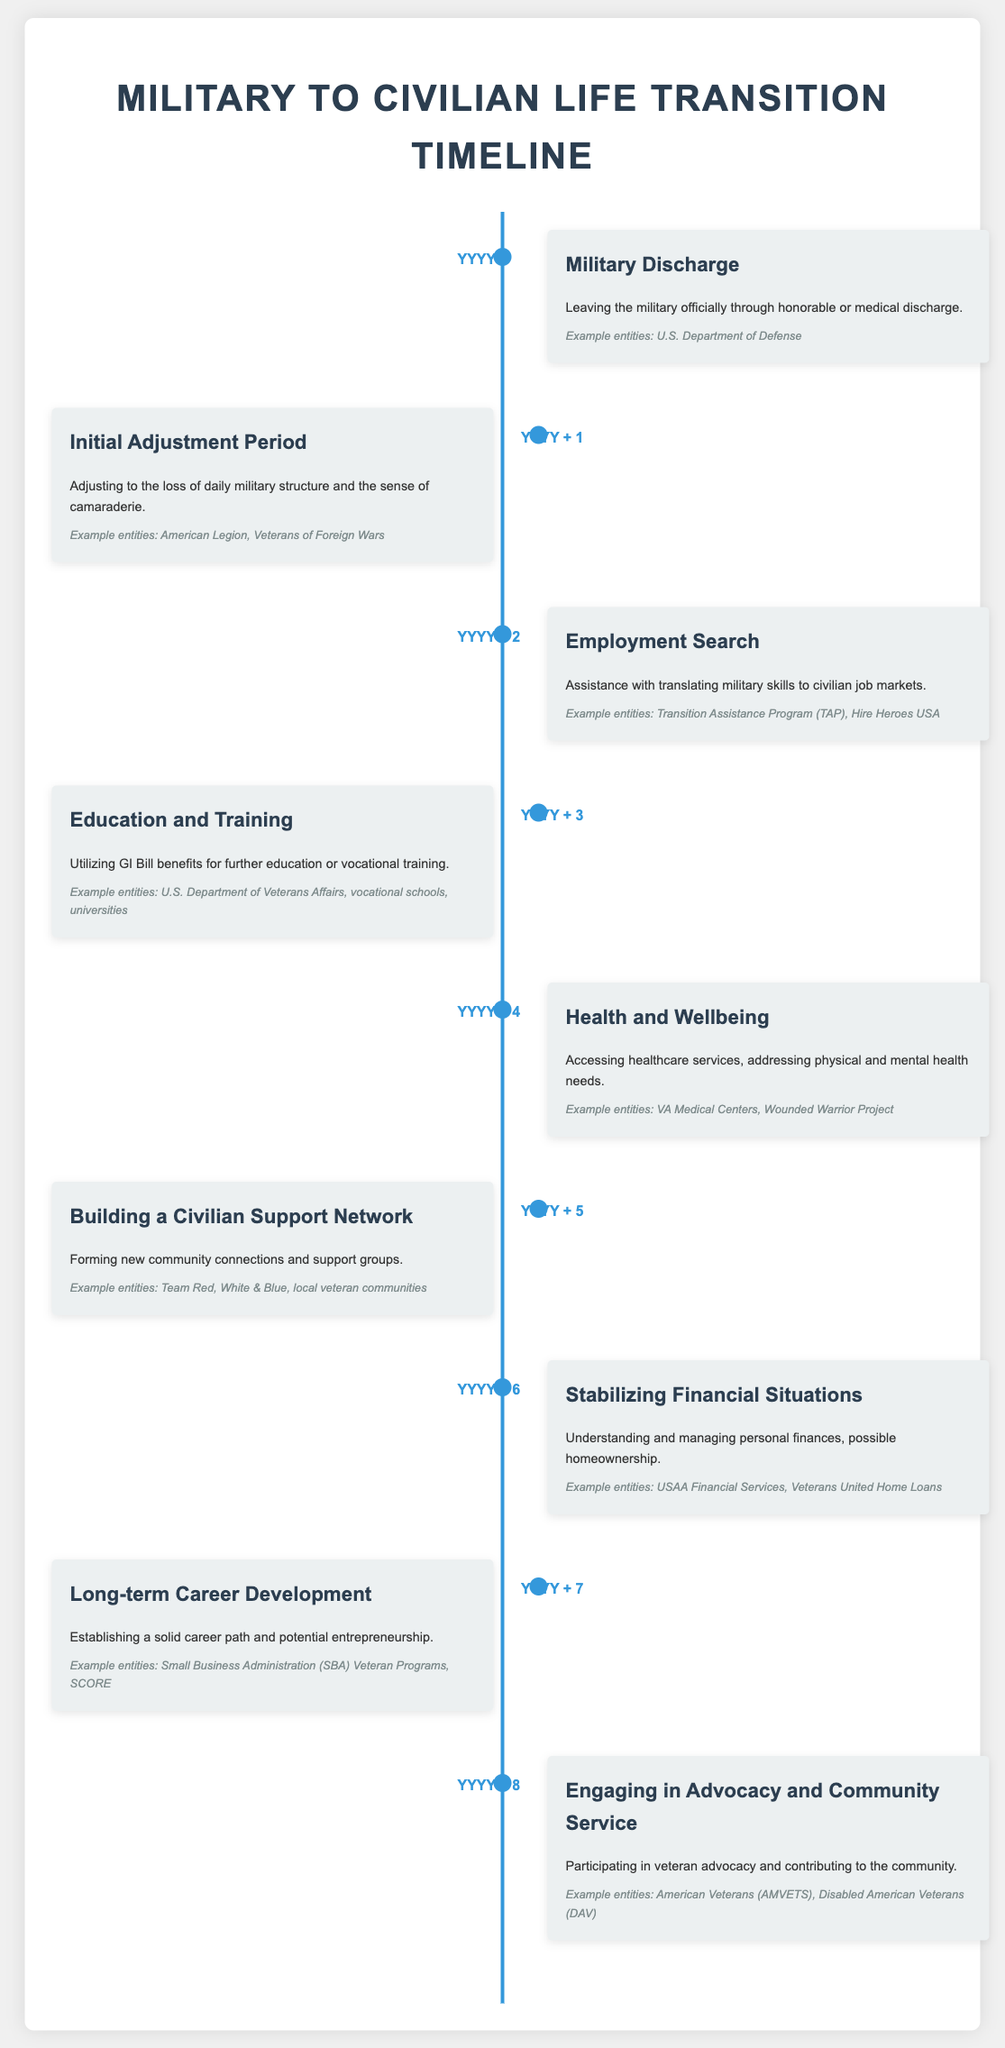What is the first milestone in the timeline? The first milestone refers to the initial event in the transition timeline, which is "Military Discharge."
Answer: Military Discharge What year does the "Employment Search" milestone occur? The "Employment Search" milestone occurs two years after the military discharge, marking it as "YYYY + 2."
Answer: YYYY + 2 What assistance program is mentioned for translating military skills? The document lists "Transition Assistance Program (TAP)" as one option for assistance.
Answer: Transition Assistance Program (TAP) What is a major focus during the "Health and Wellbeing" milestone? This milestone emphasizes the importance of accessing healthcare services and addressing both physical and mental health needs.
Answer: Accessing healthcare services Which entity is associated with community connections and support groups? The timeline includes "Team Red, White & Blue" as an example entity for building a civilian support network.
Answer: Team Red, White & Blue How long after military discharge do veterans begin "Long-term Career Development"? The timeline indicates that this phase begins "YYYY + 7," which is seven years after military discharge.
Answer: YYYY + 7 What is the purpose of the "Initial Adjustment Period"? The purpose of this period is focused on adjusting to the loss of military structure and camaraderie.
Answer: Adjusting to the loss of daily military structure Which milestone utilizes GI Bill benefits? The milestone titled "Education and Training" is focused on utilizing these benefits for further education or vocational training.
Answer: Education and Training 